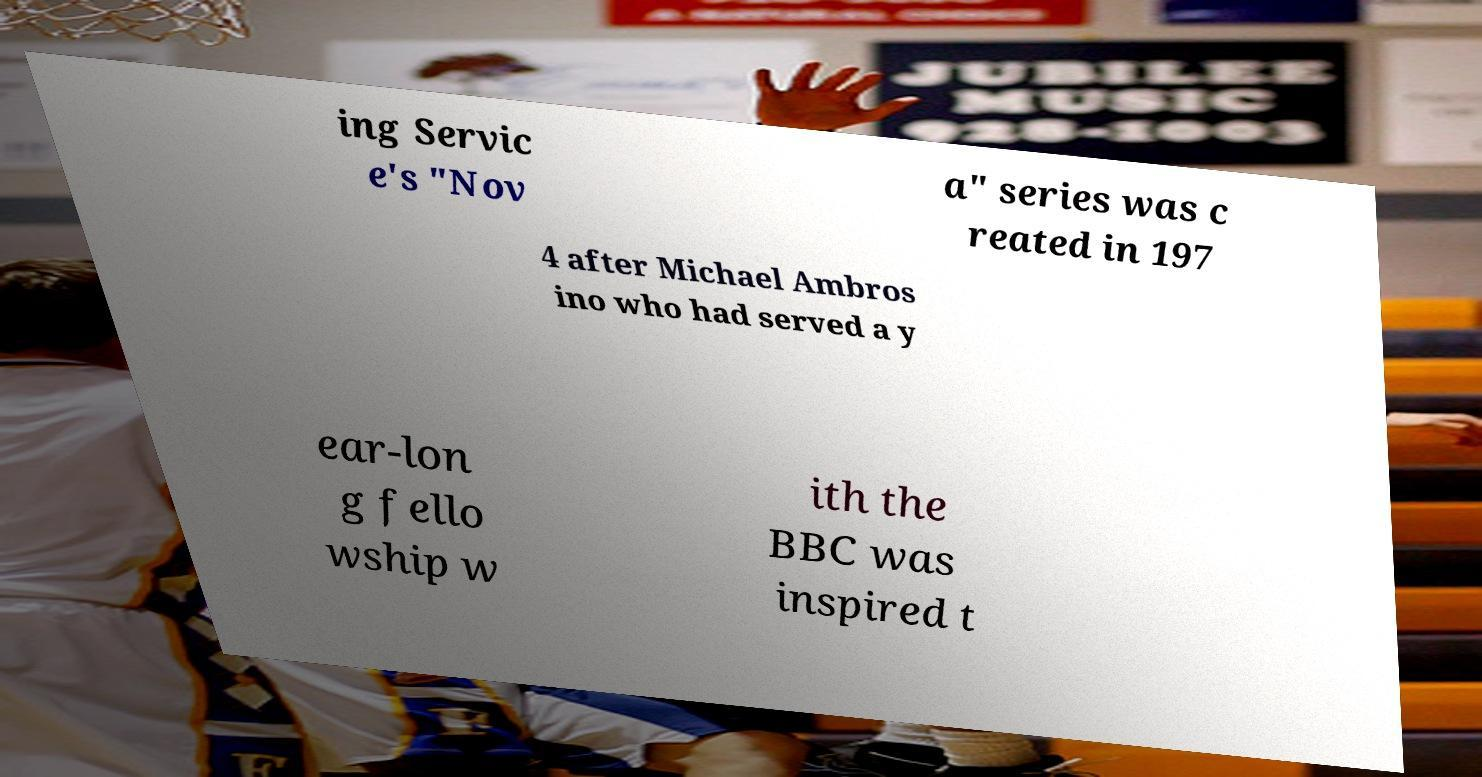For documentation purposes, I need the text within this image transcribed. Could you provide that? ing Servic e's "Nov a" series was c reated in 197 4 after Michael Ambros ino who had served a y ear-lon g fello wship w ith the BBC was inspired t 